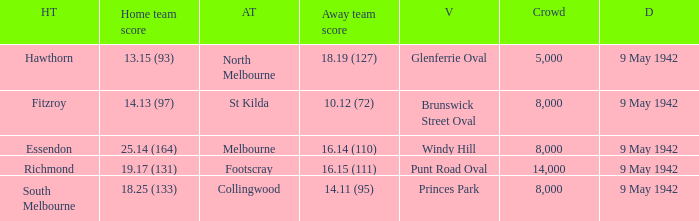How many people attended the game where Footscray was away? 14000.0. 